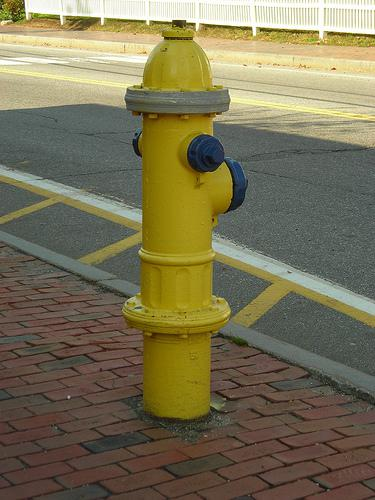Question: who is in this photo?
Choices:
A. Nobody.
B. A bear.
C. A man.
D. A famous singer.
Answer with the letter. Answer: A Question: how many people are in this photo?
Choices:
A. One.
B. None.
C. Two.
D. Three.
Answer with the letter. Answer: B Question: how many fire hydrants are there?
Choices:
A. Two.
B. One.
C. Three.
D. Four.
Answer with the letter. Answer: B Question: what color are the bricks?
Choices:
A. Brown.
B. Red.
C. Tan.
D. Grey.
Answer with the letter. Answer: B Question: what color is the curb?
Choices:
A. Yellow.
B. Gray.
C. Red.
D. Orange.
Answer with the letter. Answer: B 